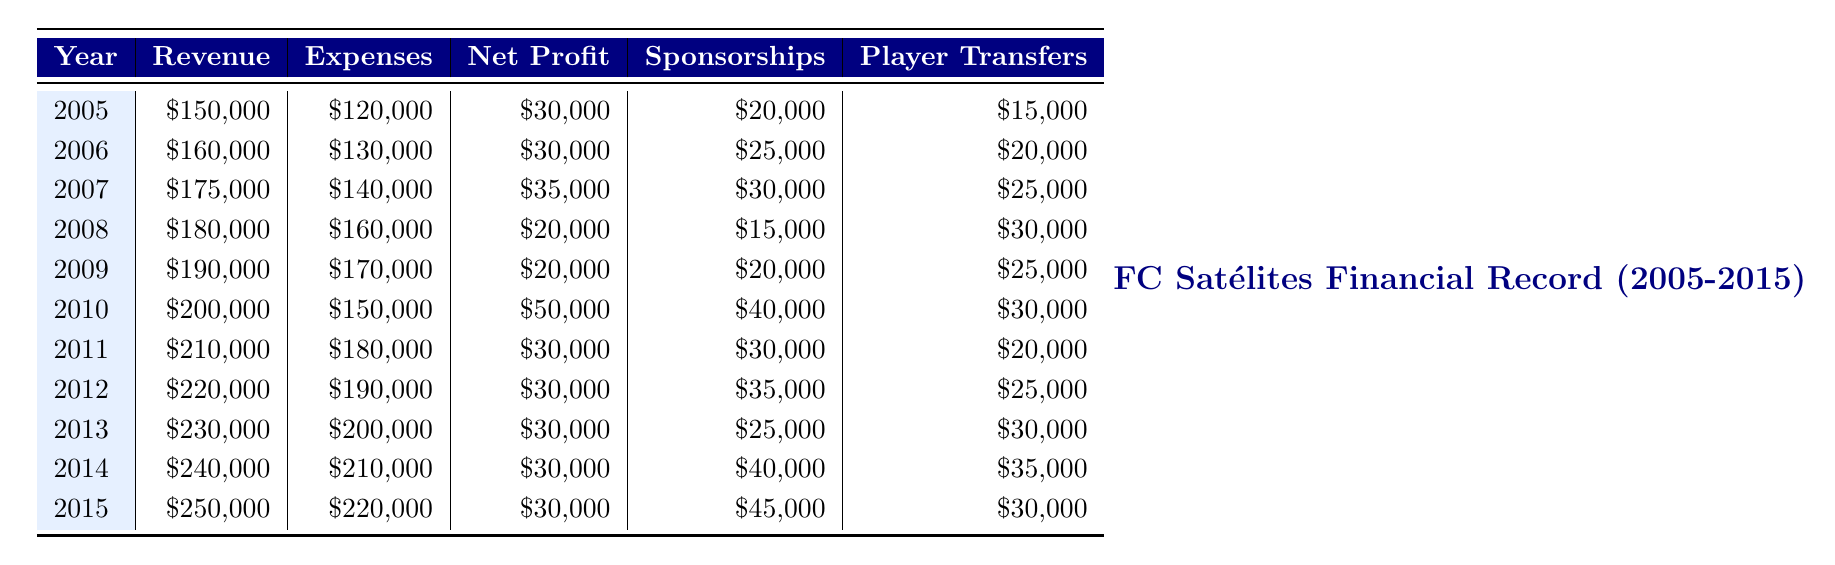What was the net profit for FC Satélites in 2012? In the table, the net profit for the year 2012 is directly provided as \$30,000.
Answer: 30000 What year had the highest revenue, and what was that amount? The year 2015 had the highest revenue listed in the table, which amounts to \$250,000.
Answer: 2015, 250000 Is it true that FC Satélites had decreasing net profits from 2008 to 2009? In the table, the net profits for 2008 and 2009 are \$20,000 in both years, indicating that the net profit did not decrease. Therefore, the statement is false.
Answer: No What was the average revenue for the FC Satélites from 2005 to 2015? To find the average revenue, sum the revenues from each year (150000 + 160000 + 175000 + 180000 + 190000 + 200000 + 210000 + 220000 + 230000 + 240000 + 250000) = 2,215,000. Divide by the number of years (11), so the average revenue is 2,215,000 / 11 = 201,363.64, rounded to 201,364.
Answer: 201364 In which year did sponsorships reach the highest amount, and what was it? By examining the sponsorships in the table, the year 2015 had the highest sponsorships recorded at \$45,000.
Answer: 2015, 45000 What was the difference between the revenue and expenses in 2010? For the year 2010, the revenue is \$200,000 and expenses are \$150,000. The difference is calculated as 200000 - 150000 = 50000.
Answer: 50000 Was there any year where FC Satélites had player transfers greater than \$30,000? Looking at the player transfers, the years 2010, 2011, 2012, and 2014 exceed the \$30,000 mark, so yes, there were multiple years with higher figures.
Answer: Yes Which year saw a significant increase in revenue compared to the previous year? Comparing revenue year by year, the jump from 2013 (\$230,000) to 2014 (\$240,000) shows an increase of \$10,000. However, the most significant increase occurs from 2009 (\$190,000) to 2010 (\$200,000) which is a \$10,000 increase too, but remained consistent since then for subsequent years. Multiple years showed a consistent growth trajectory without drastic leaps.
Answer: 2014 